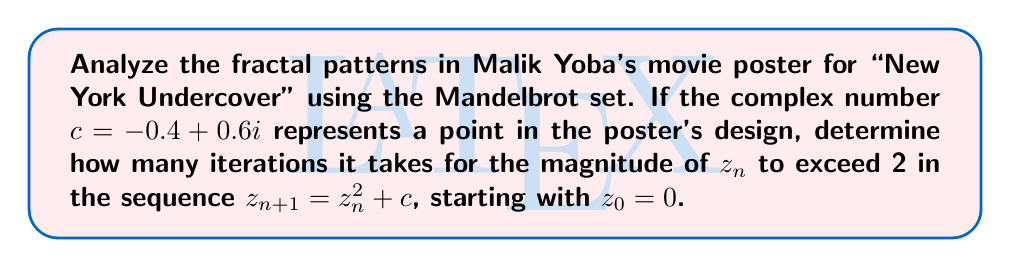Show me your answer to this math problem. To analyze this fractal pattern using the Mandelbrot set, we'll iterate the function $z_{n+1} = z_n^2 + c$ with $c = -0.4 + 0.6i$ and $z_0 = 0$. We'll continue until $|z_n| > 2$ or until we reach a maximum number of iterations.

Let's calculate step by step:

1) $z_0 = 0$

2) $z_1 = z_0^2 + c = 0^2 + (-0.4 + 0.6i) = -0.4 + 0.6i$
   $|z_1| = \sqrt{(-0.4)^2 + 0.6^2} = \sqrt{0.16 + 0.36} = \sqrt{0.52} \approx 0.721 < 2$

3) $z_2 = z_1^2 + c = (-0.4 + 0.6i)^2 + (-0.4 + 0.6i)$
   $= (0.16 - 0.48i - 0.36) + (-0.4 + 0.6i) = -0.6 + 0.12i$
   $|z_2| = \sqrt{(-0.6)^2 + 0.12^2} = \sqrt{0.36 + 0.0144} = \sqrt{0.3744} \approx 0.612 < 2$

4) $z_3 = z_2^2 + c = (-0.6 + 0.12i)^2 + (-0.4 + 0.6i)$
   $= (0.36 - 0.144i - 0.0144) + (-0.4 + 0.6i) = -0.0544 + 0.456i$
   $|z_3| = \sqrt{(-0.0544)^2 + 0.456^2} = \sqrt{0.002959 + 0.207936} = \sqrt{0.210895} \approx 0.459 < 2$

5) $z_4 = z_3^2 + c = (-0.0544 + 0.456i)^2 + (-0.4 + 0.6i)$
   $= (0.002959 - 0.049638i - 0.207936) + (-0.4 + 0.6i) = -0.604977 + 0.550362i$
   $|z_4| = \sqrt{(-0.604977)^2 + 0.550362^2} = \sqrt{0.365997 + 0.302898} = \sqrt{0.668895} \approx 0.818 < 2$

We can continue this process, but we see that after 4 iterations, the magnitude is still less than 2.
Answer: The magnitude of $z_n$ does not exceed 2 within the first 4 iterations. 